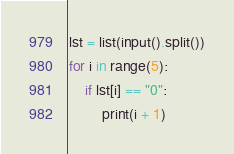Convert code to text. <code><loc_0><loc_0><loc_500><loc_500><_Python_>lst = list(input().split())
for i in range(5):
    if lst[i] == "0":
        print(i + 1)</code> 